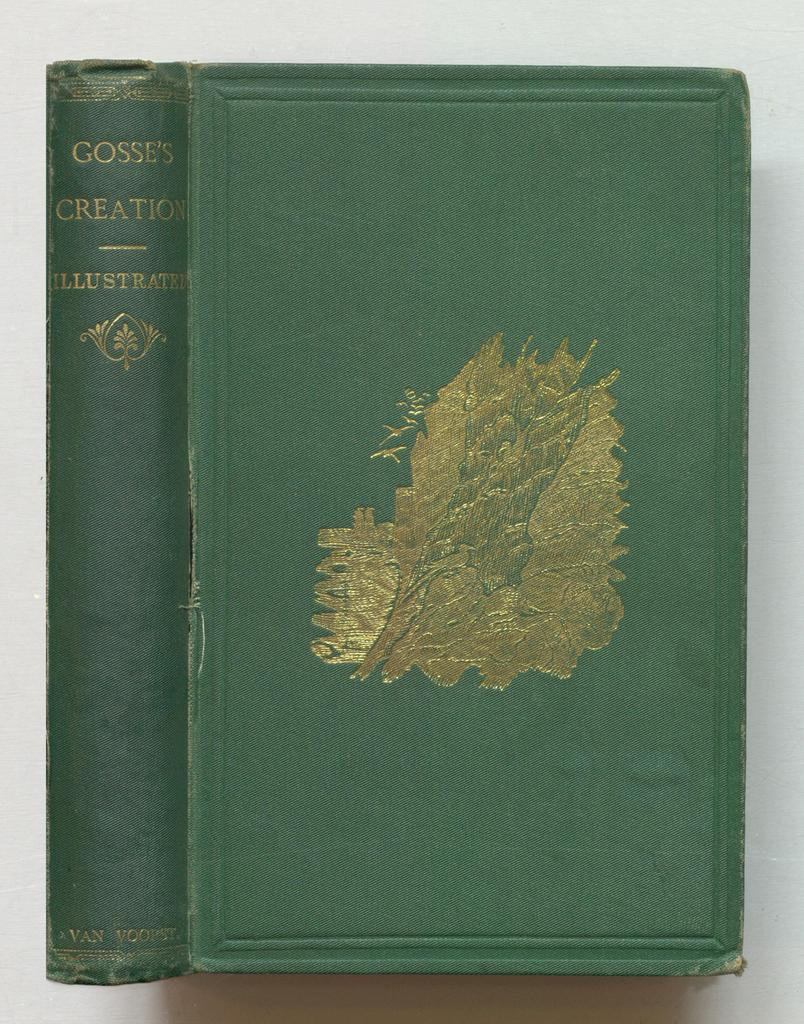<image>
Render a clear and concise summary of the photo. An old book with a green cover called Gosse's Creation is seen both front ways and sideways. 